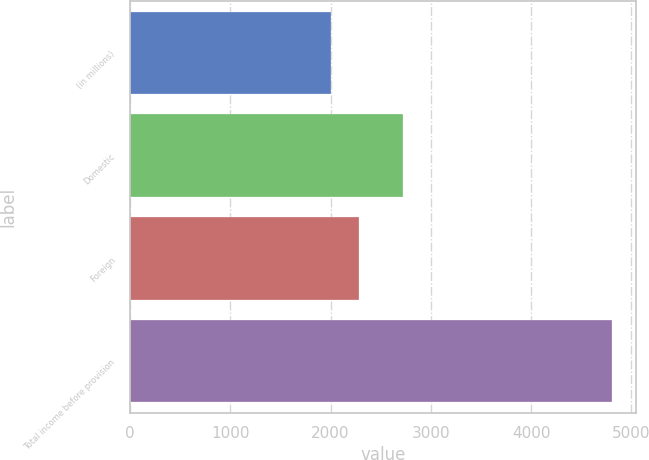Convert chart to OTSL. <chart><loc_0><loc_0><loc_500><loc_500><bar_chart><fcel>(in millions)<fcel>Domestic<fcel>Foreign<fcel>Total income before provision<nl><fcel>2006<fcel>2727<fcel>2286.4<fcel>4810<nl></chart> 